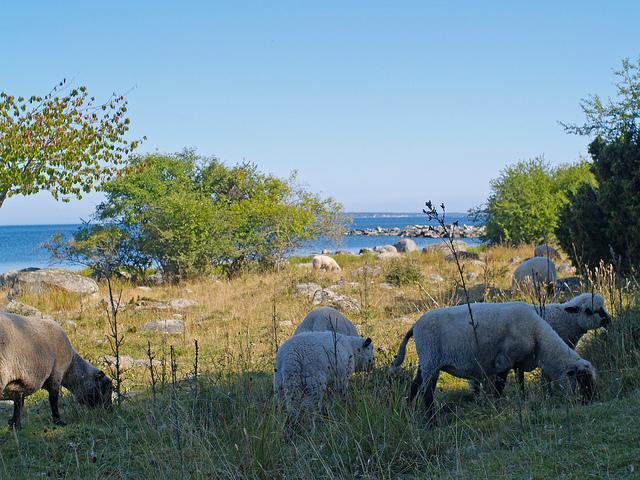How many sheep can you see?
Give a very brief answer. 4. How many men are in pants?
Give a very brief answer. 0. 